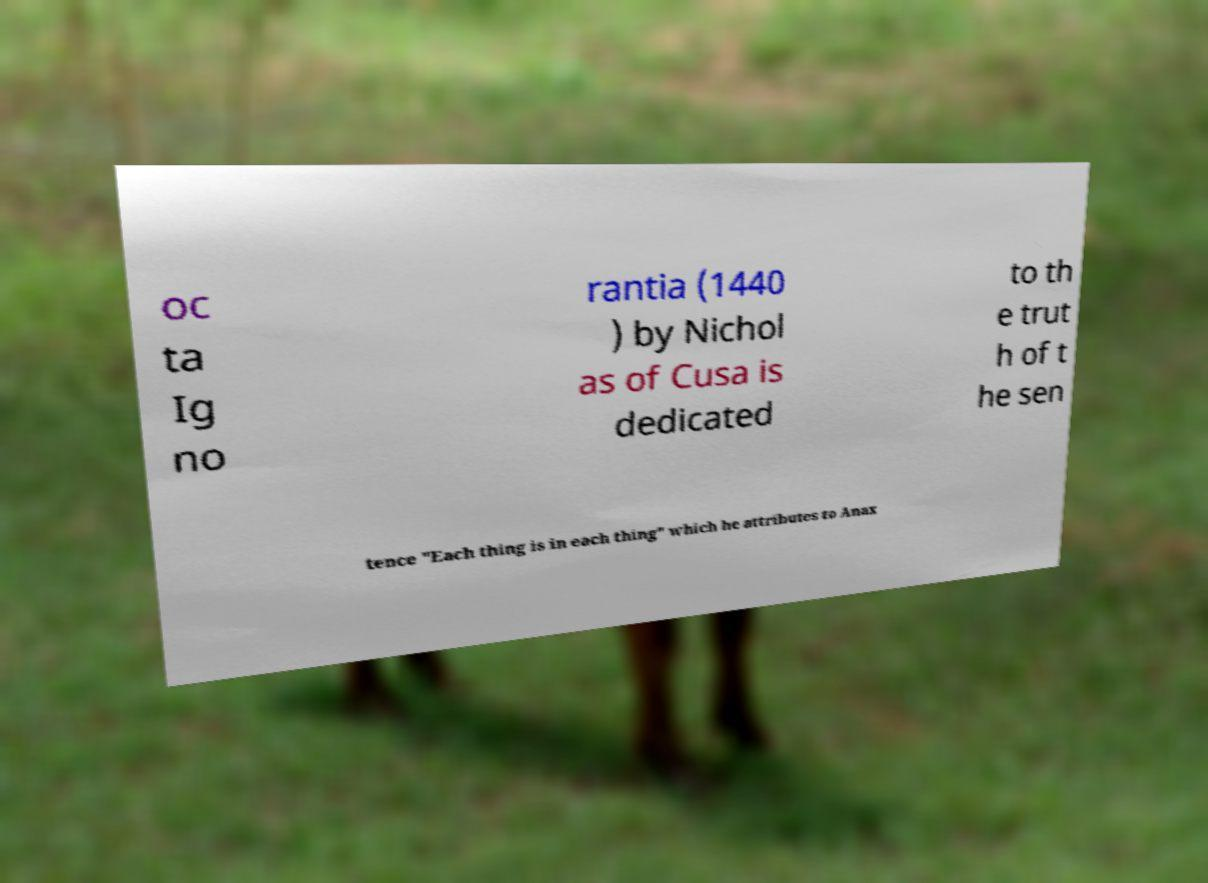Please identify and transcribe the text found in this image. oc ta Ig no rantia (1440 ) by Nichol as of Cusa is dedicated to th e trut h of t he sen tence "Each thing is in each thing" which he attributes to Anax 